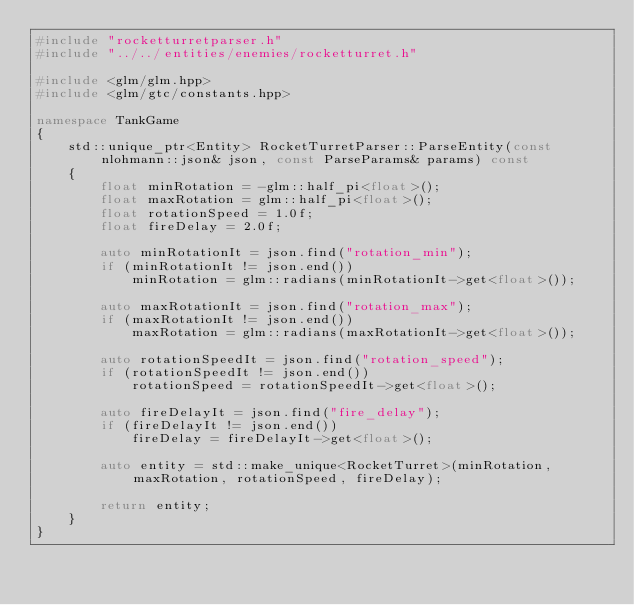Convert code to text. <code><loc_0><loc_0><loc_500><loc_500><_C++_>#include "rocketturretparser.h"
#include "../../entities/enemies/rocketturret.h"

#include <glm/glm.hpp>
#include <glm/gtc/constants.hpp>

namespace TankGame
{
	std::unique_ptr<Entity> RocketTurretParser::ParseEntity(const nlohmann::json& json, const ParseParams& params) const
	{
		float minRotation = -glm::half_pi<float>();
		float maxRotation = glm::half_pi<float>();
		float rotationSpeed = 1.0f;
		float fireDelay = 2.0f;
		
		auto minRotationIt = json.find("rotation_min");
		if (minRotationIt != json.end())
			minRotation = glm::radians(minRotationIt->get<float>());
		
		auto maxRotationIt = json.find("rotation_max");
		if (maxRotationIt != json.end())
			maxRotation = glm::radians(maxRotationIt->get<float>());
		
		auto rotationSpeedIt = json.find("rotation_speed");
		if (rotationSpeedIt != json.end())
			rotationSpeed = rotationSpeedIt->get<float>();
		
		auto fireDelayIt = json.find("fire_delay");
		if (fireDelayIt != json.end())
			fireDelay = fireDelayIt->get<float>();
		
		auto entity = std::make_unique<RocketTurret>(minRotation, maxRotation, rotationSpeed, fireDelay);
		
		return entity;
	}
}
</code> 